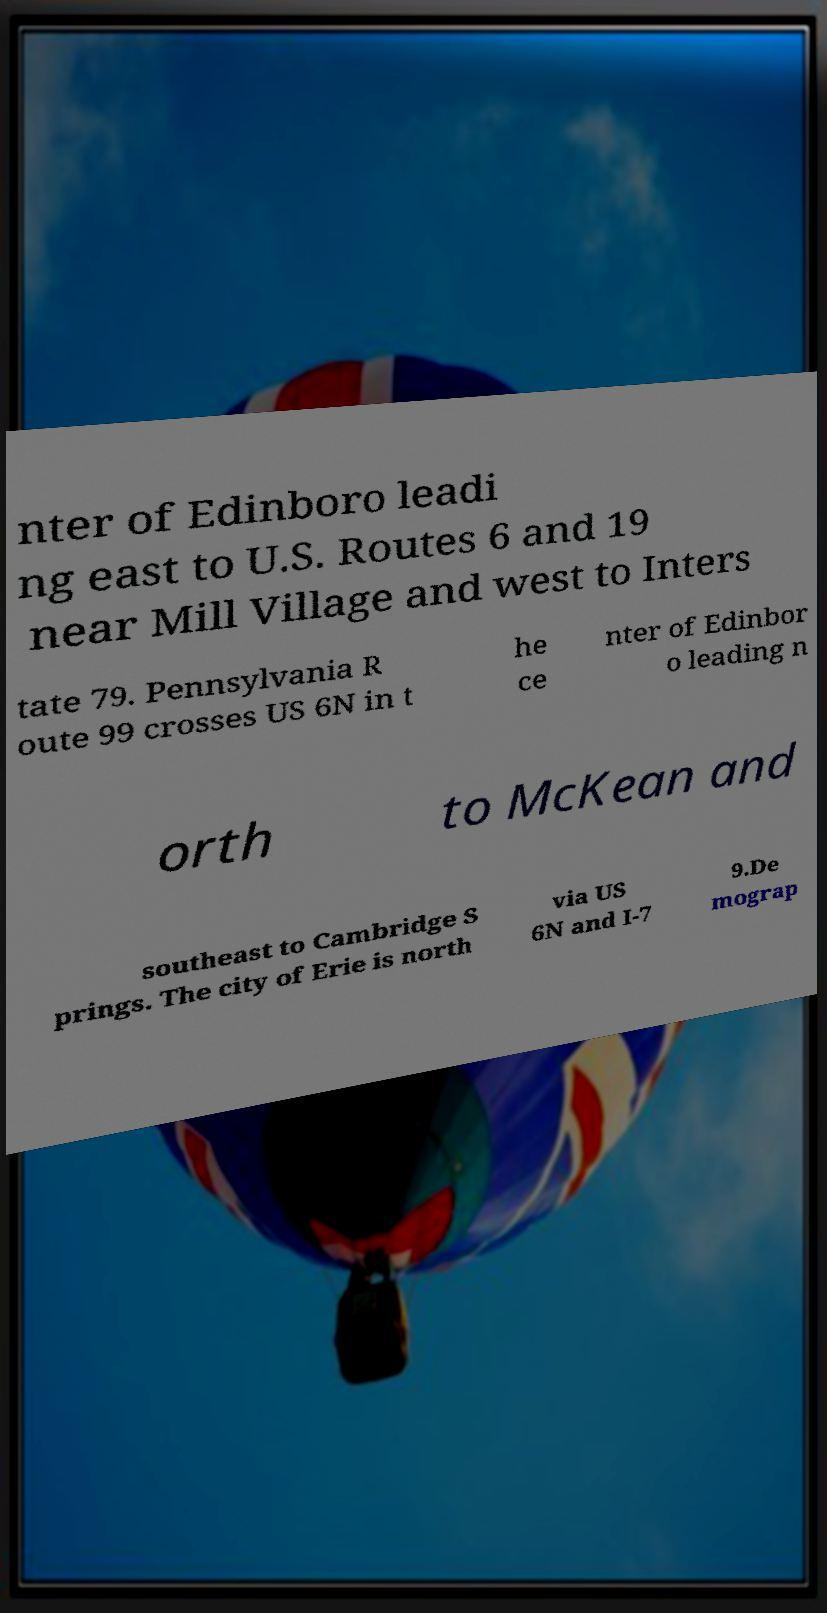Could you assist in decoding the text presented in this image and type it out clearly? nter of Edinboro leadi ng east to U.S. Routes 6 and 19 near Mill Village and west to Inters tate 79. Pennsylvania R oute 99 crosses US 6N in t he ce nter of Edinbor o leading n orth to McKean and southeast to Cambridge S prings. The city of Erie is north via US 6N and I-7 9.De mograp 